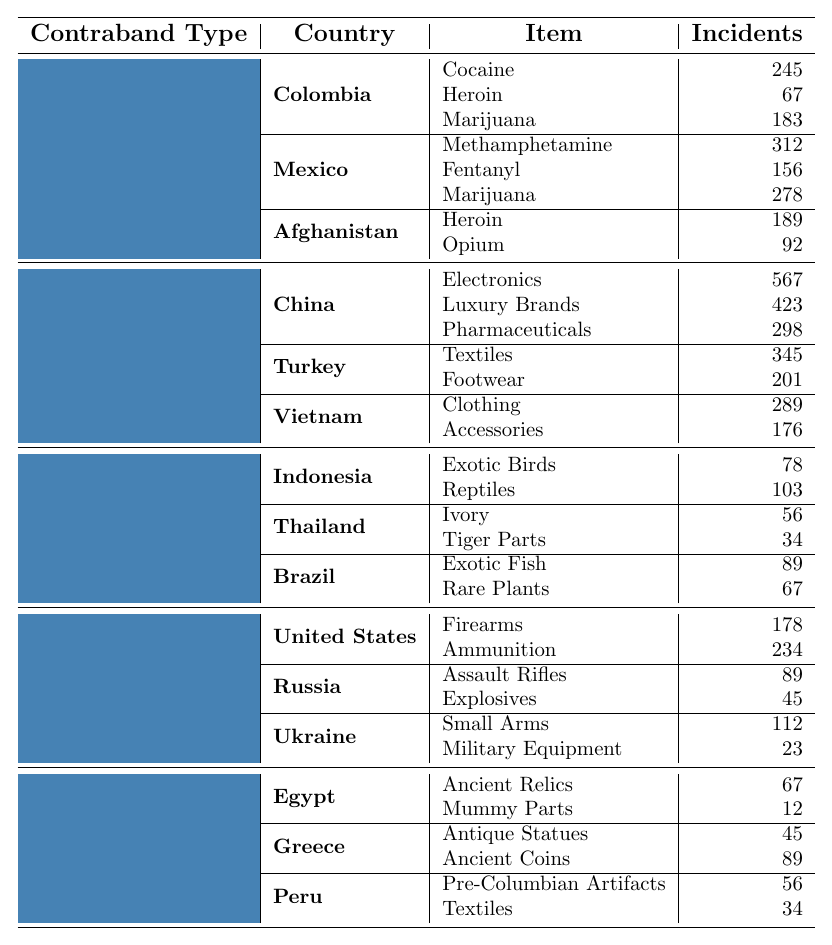What is the total number of drug-related incidents reported from Colombia? The total number of drug-related incidents from Colombia is the sum of all incidents listed under Colombia, which are: Cocaine (245), Heroin (67), and Marijuana (183). Adding these together gives 245 + 67 + 183 = 495.
Answer: 495 Which country has the highest number of counterfeit goods incidents? To find the country with the highest number of counterfeit goods incidents, we look at the totals for each country. China has 567 (Electronics) + 423 (Luxury Brands) + 298 (Pharmaceuticals) = 1288. Turkey has 345 + 201 = 546, and Vietnam has 289 + 176 = 465. Therefore, China has the highest total.
Answer: China How many wildlife incidents are reported from Thailand? The total number of wildlife incidents reported from Thailand is the sum of the incidents listed under Thailand, which are Ivory (56) and Tiger Parts (34). The total is 56 + 34 = 90.
Answer: 90 Is the number of incidents involving firearms greater than those involving ammunition in the United States? In the United States, the number of incidents involving firearms is 178, while the number involving ammunition is 234. Since 178 < 234, it is not true that the number of incidents involving firearms is greater.
Answer: No What is the combined total of incidents involving counterfeit goods from Turkey and Vietnam? To find the combined total of incidents from Turkey and Vietnam, we add the incidents from both countries. Turkey has 345 (Textiles) + 201 (Footwear) = 546, and Vietnam has 289 (Clothing) + 176 (Accessories) = 465. Adding both results gives 546 + 465 = 1011.
Answer: 1011 How many total incidents are there for Cultural Artifacts from all listed countries? To find the total for Cultural Artifacts, we sum the incidents from each country: Egypt (67 + 12 = 79), Greece (45 + 89 = 134), and Peru (56 + 34 = 90). Then, we add the three totals: 79 + 134 + 90 = 303.
Answer: 303 Which type of contraband has the least number of incidents reported from Brazil? In Brazil, the contraband types reported are Wildlife (Exotic Fish: 89 and Rare Plants: 67). To determine the least number, we can see that 67 (Rare Plants) is less than 89. Thus, the least number of incidents is regarding Rare Plants.
Answer: Rare Plants What is the sum of opium and heroin incidents reported across all countries? For this, we locate the incidents of Opium and Heroin: Afghanistan reported Heroin (189) and Opium (92). The total is 189 + 92 = 281.
Answer: 281 How many more incidents are there for marijuana compared to the incidents involving luxury brands? The total number of incidents involving Marijuana is 278 (Mexico) + 183 (Colombia) = 461. The incidents involving Luxury Brands total 423 (China). Thus, 461 - 423 = 38 more incidents for Marijuana.
Answer: 38 Are there more incidents involving Exotic Birds than Antique Statues? Exotic Birds have a total of 78 incidents (Indonesia), while Antique Statues have 45 (Greece). Since 78 > 45, there are more incidents involving Exotic Birds.
Answer: Yes 